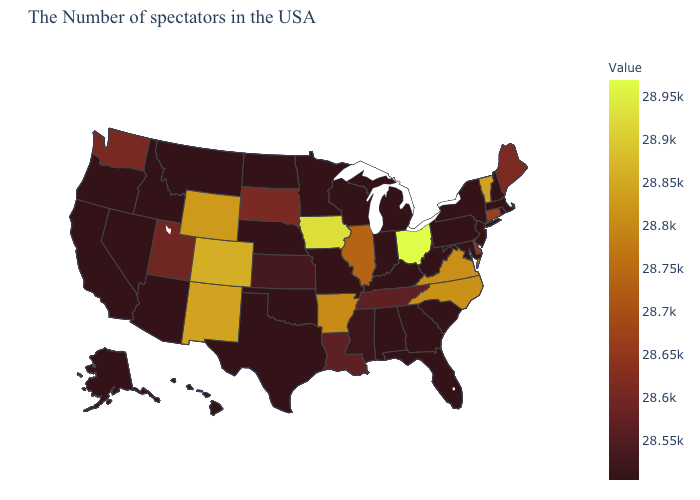Among the states that border Wyoming , which have the highest value?
Keep it brief. Colorado. Among the states that border Missouri , which have the highest value?
Concise answer only. Iowa. Does Wyoming have a higher value than Ohio?
Concise answer only. No. Among the states that border Wisconsin , does Iowa have the lowest value?
Concise answer only. No. Does Oklahoma have the lowest value in the South?
Keep it brief. Yes. 